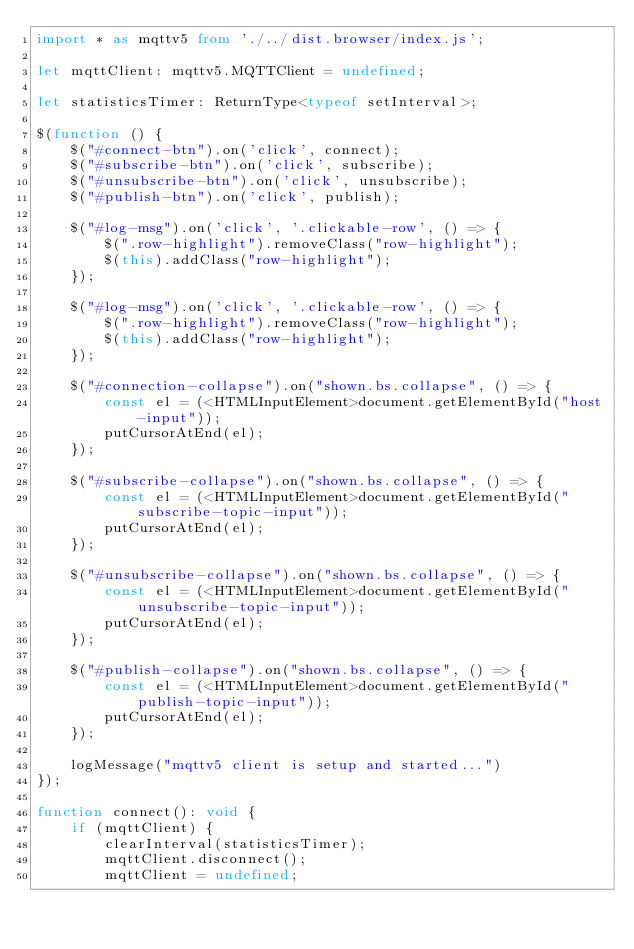<code> <loc_0><loc_0><loc_500><loc_500><_TypeScript_>import * as mqttv5 from './../dist.browser/index.js';

let mqttClient: mqttv5.MQTTClient = undefined;

let statisticsTimer: ReturnType<typeof setInterval>;

$(function () {
    $("#connect-btn").on('click', connect);
    $("#subscribe-btn").on('click', subscribe);
    $("#unsubscribe-btn").on('click', unsubscribe);
    $("#publish-btn").on('click', publish);

    $("#log-msg").on('click', '.clickable-row', () => {
        $(".row-highlight").removeClass("row-highlight");
        $(this).addClass("row-highlight");
    });

    $("#log-msg").on('click', '.clickable-row', () => {
        $(".row-highlight").removeClass("row-highlight");
        $(this).addClass("row-highlight");
    });

    $("#connection-collapse").on("shown.bs.collapse", () => {
        const el = (<HTMLInputElement>document.getElementById("host-input"));
        putCursorAtEnd(el);
    });

    $("#subscribe-collapse").on("shown.bs.collapse", () => {
        const el = (<HTMLInputElement>document.getElementById("subscribe-topic-input"));
        putCursorAtEnd(el);
    });

    $("#unsubscribe-collapse").on("shown.bs.collapse", () => {
        const el = (<HTMLInputElement>document.getElementById("unsubscribe-topic-input"));
        putCursorAtEnd(el);
    });

    $("#publish-collapse").on("shown.bs.collapse", () => {
        const el = (<HTMLInputElement>document.getElementById("publish-topic-input"));
        putCursorAtEnd(el);
    });

    logMessage("mqttv5 client is setup and started...")
});

function connect(): void {
    if (mqttClient) {
        clearInterval(statisticsTimer);
        mqttClient.disconnect();
        mqttClient = undefined;</code> 